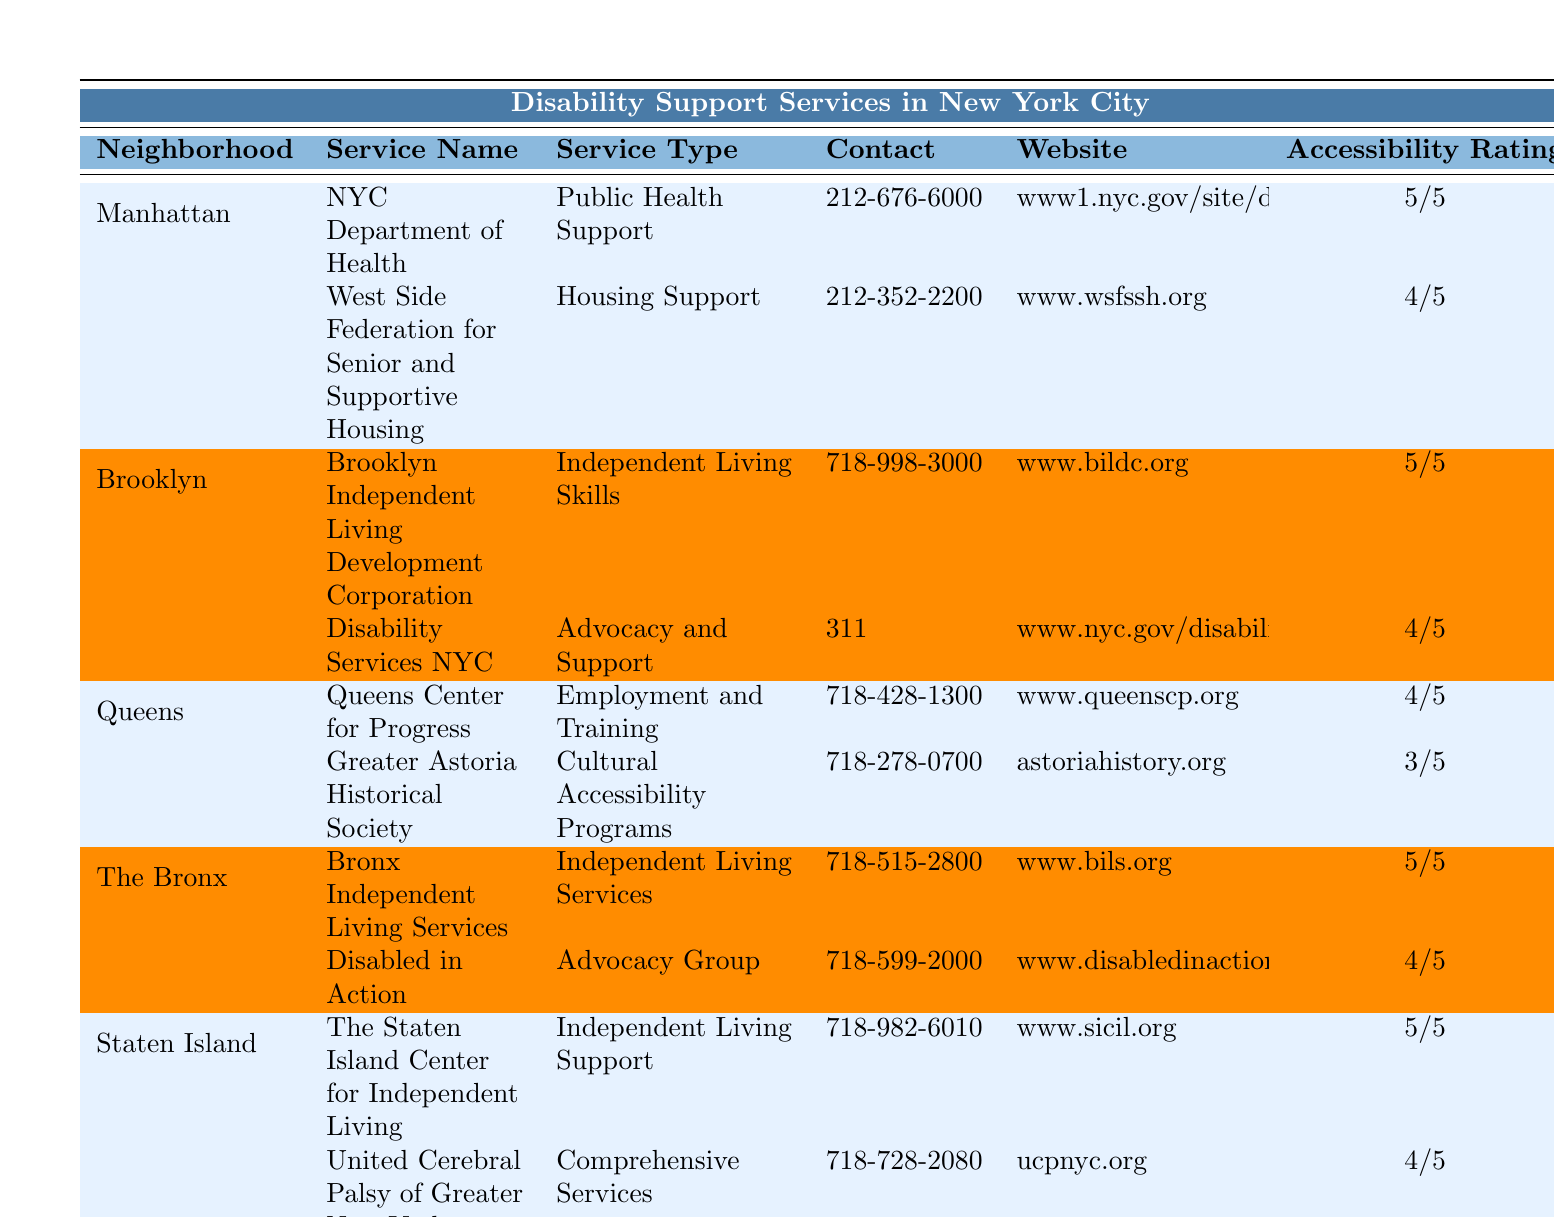What is the contact number for the NYC Department of Health in Manhattan? From the table, under the Manhattan neighborhood section, the NYC Department of Health has the contact number 212-676-6000 listed.
Answer: 212-676-6000 How many services are available in the Bronx? The Bronx has two services listed in the table: Bronx Independent Living Services and Disabled in Action. Therefore, the total number of services is 2.
Answer: 2 Which neighborhood has the highest accessibility rating? The accessibility ratings for services in each neighborhood are compared. The Bronx and Staten Island both have services rated 5/5, which is the highest rating.
Answer: Bronx and Staten Island Is there a cultural accessibility program available in Queens? The table lists Greater Astoria Historical Society under Queens as providing cultural accessibility programs. Therefore, the answer is yes.
Answer: Yes What is the average accessibility rating of the services in Brooklyn? The services in Brooklyn have ratings of 5/5 and 4/5. The average is calculated as (5 + 4) / 2 = 4.5, which can also be expressed as 4.5/5.
Answer: 4.5/5 Which service in Staten Island has the lowest accessibility rating? The services in Staten Island are rated 5/5 and 4/5. The one with the lowest rating is United Cerebral Palsy of Greater New York with an accessibility rating of 4/5.
Answer: United Cerebral Palsy of Greater New York How many different service types are listed in the table? By examining the service types across different neighborhoods, we find: Public Health Support, Housing Support, Independent Living Skills, Advocacy and Support, Employment and Training, Cultural Accessibility Programs, Independent Living Services, Advocacy Group, Independent Living Support, and Comprehensive Services. Counting these gives a total of 10 unique service types.
Answer: 10 In which neighborhood is the Brooklyn Independent Living Development Corporation located? The Brooklyn Independent Living Development Corporation is specifically listed under the Brooklyn neighborhood section in the table.
Answer: Brooklyn What service type is provided by the Queens Center for Progress? Referring to the Queen neighborhood section of the table, the Queens Center for Progress provides Employment and Training services.
Answer: Employment and Training Are there any services in The Bronx that provide Independent Living Support? The table shows Bronx Independent Living Services as providing Independent Living Services, so yes, there is a service of that type in The Bronx.
Answer: Yes 